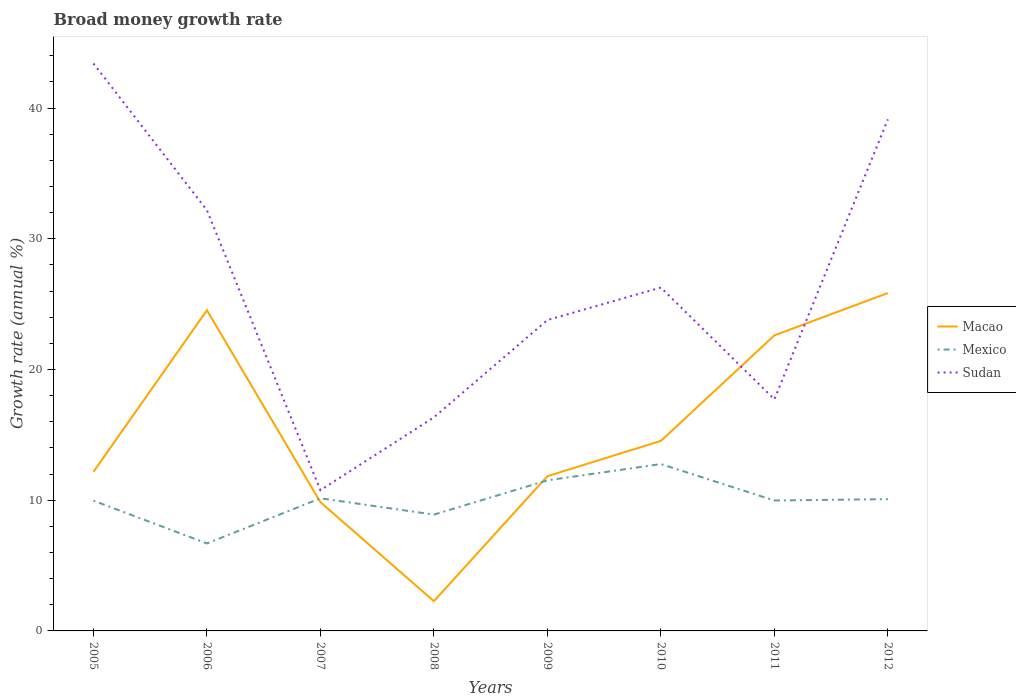How many different coloured lines are there?
Give a very brief answer. 3. Across all years, what is the maximum growth rate in Sudan?
Your response must be concise. 10.77. What is the total growth rate in Mexico in the graph?
Your answer should be very brief. -2.8. What is the difference between the highest and the second highest growth rate in Mexico?
Offer a terse response. 6.07. What is the difference between the highest and the lowest growth rate in Mexico?
Make the answer very short. 4. Is the growth rate in Mexico strictly greater than the growth rate in Sudan over the years?
Make the answer very short. Yes. How many lines are there?
Your answer should be very brief. 3. How many years are there in the graph?
Give a very brief answer. 8. What is the difference between two consecutive major ticks on the Y-axis?
Make the answer very short. 10. Are the values on the major ticks of Y-axis written in scientific E-notation?
Ensure brevity in your answer.  No. Does the graph contain grids?
Offer a terse response. No. How many legend labels are there?
Offer a very short reply. 3. What is the title of the graph?
Your answer should be very brief. Broad money growth rate. What is the label or title of the Y-axis?
Give a very brief answer. Growth rate (annual %). What is the Growth rate (annual %) of Macao in 2005?
Offer a terse response. 12.17. What is the Growth rate (annual %) of Mexico in 2005?
Your answer should be compact. 9.97. What is the Growth rate (annual %) of Sudan in 2005?
Provide a short and direct response. 43.42. What is the Growth rate (annual %) of Macao in 2006?
Your answer should be compact. 24.54. What is the Growth rate (annual %) of Mexico in 2006?
Keep it short and to the point. 6.69. What is the Growth rate (annual %) of Sudan in 2006?
Your answer should be very brief. 32.19. What is the Growth rate (annual %) of Macao in 2007?
Your response must be concise. 9.85. What is the Growth rate (annual %) in Mexico in 2007?
Ensure brevity in your answer.  10.15. What is the Growth rate (annual %) of Sudan in 2007?
Your answer should be compact. 10.77. What is the Growth rate (annual %) of Macao in 2008?
Your response must be concise. 2.28. What is the Growth rate (annual %) in Mexico in 2008?
Make the answer very short. 8.9. What is the Growth rate (annual %) of Sudan in 2008?
Keep it short and to the point. 16.34. What is the Growth rate (annual %) in Macao in 2009?
Provide a short and direct response. 11.84. What is the Growth rate (annual %) in Mexico in 2009?
Offer a terse response. 11.52. What is the Growth rate (annual %) in Sudan in 2009?
Keep it short and to the point. 23.79. What is the Growth rate (annual %) in Macao in 2010?
Provide a succinct answer. 14.54. What is the Growth rate (annual %) in Mexico in 2010?
Offer a very short reply. 12.77. What is the Growth rate (annual %) in Sudan in 2010?
Make the answer very short. 26.27. What is the Growth rate (annual %) of Macao in 2011?
Keep it short and to the point. 22.61. What is the Growth rate (annual %) of Mexico in 2011?
Provide a succinct answer. 9.98. What is the Growth rate (annual %) of Sudan in 2011?
Offer a terse response. 17.72. What is the Growth rate (annual %) in Macao in 2012?
Provide a succinct answer. 25.85. What is the Growth rate (annual %) in Mexico in 2012?
Make the answer very short. 10.08. What is the Growth rate (annual %) in Sudan in 2012?
Give a very brief answer. 39.14. Across all years, what is the maximum Growth rate (annual %) in Macao?
Provide a succinct answer. 25.85. Across all years, what is the maximum Growth rate (annual %) of Mexico?
Keep it short and to the point. 12.77. Across all years, what is the maximum Growth rate (annual %) of Sudan?
Your answer should be compact. 43.42. Across all years, what is the minimum Growth rate (annual %) of Macao?
Your answer should be compact. 2.28. Across all years, what is the minimum Growth rate (annual %) of Mexico?
Keep it short and to the point. 6.69. Across all years, what is the minimum Growth rate (annual %) in Sudan?
Your answer should be compact. 10.77. What is the total Growth rate (annual %) of Macao in the graph?
Make the answer very short. 123.68. What is the total Growth rate (annual %) of Mexico in the graph?
Your answer should be very brief. 80.06. What is the total Growth rate (annual %) of Sudan in the graph?
Give a very brief answer. 209.64. What is the difference between the Growth rate (annual %) in Macao in 2005 and that in 2006?
Offer a terse response. -12.37. What is the difference between the Growth rate (annual %) of Mexico in 2005 and that in 2006?
Keep it short and to the point. 3.28. What is the difference between the Growth rate (annual %) in Sudan in 2005 and that in 2006?
Your answer should be very brief. 11.23. What is the difference between the Growth rate (annual %) of Macao in 2005 and that in 2007?
Your answer should be compact. 2.32. What is the difference between the Growth rate (annual %) of Mexico in 2005 and that in 2007?
Your answer should be very brief. -0.18. What is the difference between the Growth rate (annual %) in Sudan in 2005 and that in 2007?
Your answer should be compact. 32.65. What is the difference between the Growth rate (annual %) of Macao in 2005 and that in 2008?
Your response must be concise. 9.89. What is the difference between the Growth rate (annual %) in Mexico in 2005 and that in 2008?
Provide a succinct answer. 1.07. What is the difference between the Growth rate (annual %) in Sudan in 2005 and that in 2008?
Your answer should be compact. 27.08. What is the difference between the Growth rate (annual %) in Macao in 2005 and that in 2009?
Offer a very short reply. 0.33. What is the difference between the Growth rate (annual %) in Mexico in 2005 and that in 2009?
Your answer should be compact. -1.55. What is the difference between the Growth rate (annual %) of Sudan in 2005 and that in 2009?
Provide a short and direct response. 19.63. What is the difference between the Growth rate (annual %) in Macao in 2005 and that in 2010?
Give a very brief answer. -2.37. What is the difference between the Growth rate (annual %) in Mexico in 2005 and that in 2010?
Ensure brevity in your answer.  -2.8. What is the difference between the Growth rate (annual %) in Sudan in 2005 and that in 2010?
Offer a very short reply. 17.14. What is the difference between the Growth rate (annual %) of Macao in 2005 and that in 2011?
Provide a succinct answer. -10.44. What is the difference between the Growth rate (annual %) in Mexico in 2005 and that in 2011?
Make the answer very short. -0.01. What is the difference between the Growth rate (annual %) of Sudan in 2005 and that in 2011?
Ensure brevity in your answer.  25.7. What is the difference between the Growth rate (annual %) of Macao in 2005 and that in 2012?
Keep it short and to the point. -13.68. What is the difference between the Growth rate (annual %) of Mexico in 2005 and that in 2012?
Make the answer very short. -0.12. What is the difference between the Growth rate (annual %) in Sudan in 2005 and that in 2012?
Ensure brevity in your answer.  4.28. What is the difference between the Growth rate (annual %) of Macao in 2006 and that in 2007?
Make the answer very short. 14.69. What is the difference between the Growth rate (annual %) in Mexico in 2006 and that in 2007?
Make the answer very short. -3.46. What is the difference between the Growth rate (annual %) in Sudan in 2006 and that in 2007?
Make the answer very short. 21.42. What is the difference between the Growth rate (annual %) in Macao in 2006 and that in 2008?
Offer a terse response. 22.26. What is the difference between the Growth rate (annual %) in Mexico in 2006 and that in 2008?
Provide a succinct answer. -2.21. What is the difference between the Growth rate (annual %) in Sudan in 2006 and that in 2008?
Keep it short and to the point. 15.85. What is the difference between the Growth rate (annual %) of Macao in 2006 and that in 2009?
Ensure brevity in your answer.  12.7. What is the difference between the Growth rate (annual %) of Mexico in 2006 and that in 2009?
Provide a succinct answer. -4.83. What is the difference between the Growth rate (annual %) in Sudan in 2006 and that in 2009?
Your response must be concise. 8.4. What is the difference between the Growth rate (annual %) in Macao in 2006 and that in 2010?
Your response must be concise. 10. What is the difference between the Growth rate (annual %) in Mexico in 2006 and that in 2010?
Provide a short and direct response. -6.07. What is the difference between the Growth rate (annual %) of Sudan in 2006 and that in 2010?
Provide a short and direct response. 5.92. What is the difference between the Growth rate (annual %) of Macao in 2006 and that in 2011?
Give a very brief answer. 1.92. What is the difference between the Growth rate (annual %) in Mexico in 2006 and that in 2011?
Give a very brief answer. -3.29. What is the difference between the Growth rate (annual %) in Sudan in 2006 and that in 2011?
Your response must be concise. 14.47. What is the difference between the Growth rate (annual %) in Macao in 2006 and that in 2012?
Keep it short and to the point. -1.31. What is the difference between the Growth rate (annual %) in Mexico in 2006 and that in 2012?
Make the answer very short. -3.39. What is the difference between the Growth rate (annual %) of Sudan in 2006 and that in 2012?
Ensure brevity in your answer.  -6.95. What is the difference between the Growth rate (annual %) in Macao in 2007 and that in 2008?
Offer a terse response. 7.57. What is the difference between the Growth rate (annual %) in Mexico in 2007 and that in 2008?
Ensure brevity in your answer.  1.25. What is the difference between the Growth rate (annual %) of Sudan in 2007 and that in 2008?
Provide a succinct answer. -5.57. What is the difference between the Growth rate (annual %) of Macao in 2007 and that in 2009?
Keep it short and to the point. -1.99. What is the difference between the Growth rate (annual %) of Mexico in 2007 and that in 2009?
Provide a short and direct response. -1.37. What is the difference between the Growth rate (annual %) in Sudan in 2007 and that in 2009?
Make the answer very short. -13.02. What is the difference between the Growth rate (annual %) of Macao in 2007 and that in 2010?
Provide a short and direct response. -4.69. What is the difference between the Growth rate (annual %) of Mexico in 2007 and that in 2010?
Give a very brief answer. -2.62. What is the difference between the Growth rate (annual %) in Sudan in 2007 and that in 2010?
Keep it short and to the point. -15.5. What is the difference between the Growth rate (annual %) of Macao in 2007 and that in 2011?
Ensure brevity in your answer.  -12.76. What is the difference between the Growth rate (annual %) of Mexico in 2007 and that in 2011?
Provide a short and direct response. 0.17. What is the difference between the Growth rate (annual %) of Sudan in 2007 and that in 2011?
Provide a succinct answer. -6.95. What is the difference between the Growth rate (annual %) in Macao in 2007 and that in 2012?
Your answer should be very brief. -16. What is the difference between the Growth rate (annual %) of Mexico in 2007 and that in 2012?
Make the answer very short. 0.06. What is the difference between the Growth rate (annual %) in Sudan in 2007 and that in 2012?
Offer a terse response. -28.37. What is the difference between the Growth rate (annual %) in Macao in 2008 and that in 2009?
Keep it short and to the point. -9.56. What is the difference between the Growth rate (annual %) in Mexico in 2008 and that in 2009?
Offer a terse response. -2.62. What is the difference between the Growth rate (annual %) of Sudan in 2008 and that in 2009?
Ensure brevity in your answer.  -7.45. What is the difference between the Growth rate (annual %) of Macao in 2008 and that in 2010?
Your answer should be very brief. -12.26. What is the difference between the Growth rate (annual %) of Mexico in 2008 and that in 2010?
Your answer should be very brief. -3.87. What is the difference between the Growth rate (annual %) in Sudan in 2008 and that in 2010?
Provide a succinct answer. -9.93. What is the difference between the Growth rate (annual %) of Macao in 2008 and that in 2011?
Keep it short and to the point. -20.34. What is the difference between the Growth rate (annual %) of Mexico in 2008 and that in 2011?
Offer a very short reply. -1.08. What is the difference between the Growth rate (annual %) of Sudan in 2008 and that in 2011?
Keep it short and to the point. -1.38. What is the difference between the Growth rate (annual %) of Macao in 2008 and that in 2012?
Give a very brief answer. -23.57. What is the difference between the Growth rate (annual %) of Mexico in 2008 and that in 2012?
Your response must be concise. -1.19. What is the difference between the Growth rate (annual %) in Sudan in 2008 and that in 2012?
Offer a terse response. -22.8. What is the difference between the Growth rate (annual %) of Macao in 2009 and that in 2010?
Ensure brevity in your answer.  -2.7. What is the difference between the Growth rate (annual %) in Mexico in 2009 and that in 2010?
Your response must be concise. -1.25. What is the difference between the Growth rate (annual %) of Sudan in 2009 and that in 2010?
Provide a succinct answer. -2.49. What is the difference between the Growth rate (annual %) of Macao in 2009 and that in 2011?
Your answer should be compact. -10.77. What is the difference between the Growth rate (annual %) of Mexico in 2009 and that in 2011?
Your response must be concise. 1.54. What is the difference between the Growth rate (annual %) in Sudan in 2009 and that in 2011?
Provide a short and direct response. 6.07. What is the difference between the Growth rate (annual %) in Macao in 2009 and that in 2012?
Offer a very short reply. -14.01. What is the difference between the Growth rate (annual %) of Mexico in 2009 and that in 2012?
Make the answer very short. 1.44. What is the difference between the Growth rate (annual %) of Sudan in 2009 and that in 2012?
Provide a short and direct response. -15.35. What is the difference between the Growth rate (annual %) in Macao in 2010 and that in 2011?
Your answer should be compact. -8.07. What is the difference between the Growth rate (annual %) in Mexico in 2010 and that in 2011?
Make the answer very short. 2.79. What is the difference between the Growth rate (annual %) of Sudan in 2010 and that in 2011?
Offer a very short reply. 8.55. What is the difference between the Growth rate (annual %) of Macao in 2010 and that in 2012?
Provide a succinct answer. -11.31. What is the difference between the Growth rate (annual %) of Mexico in 2010 and that in 2012?
Offer a very short reply. 2.68. What is the difference between the Growth rate (annual %) in Sudan in 2010 and that in 2012?
Ensure brevity in your answer.  -12.87. What is the difference between the Growth rate (annual %) in Macao in 2011 and that in 2012?
Provide a short and direct response. -3.24. What is the difference between the Growth rate (annual %) in Mexico in 2011 and that in 2012?
Ensure brevity in your answer.  -0.1. What is the difference between the Growth rate (annual %) in Sudan in 2011 and that in 2012?
Offer a terse response. -21.42. What is the difference between the Growth rate (annual %) of Macao in 2005 and the Growth rate (annual %) of Mexico in 2006?
Your answer should be compact. 5.48. What is the difference between the Growth rate (annual %) of Macao in 2005 and the Growth rate (annual %) of Sudan in 2006?
Provide a short and direct response. -20.02. What is the difference between the Growth rate (annual %) of Mexico in 2005 and the Growth rate (annual %) of Sudan in 2006?
Offer a very short reply. -22.22. What is the difference between the Growth rate (annual %) of Macao in 2005 and the Growth rate (annual %) of Mexico in 2007?
Your answer should be compact. 2.02. What is the difference between the Growth rate (annual %) in Macao in 2005 and the Growth rate (annual %) in Sudan in 2007?
Your response must be concise. 1.4. What is the difference between the Growth rate (annual %) of Mexico in 2005 and the Growth rate (annual %) of Sudan in 2007?
Provide a succinct answer. -0.8. What is the difference between the Growth rate (annual %) of Macao in 2005 and the Growth rate (annual %) of Mexico in 2008?
Your response must be concise. 3.27. What is the difference between the Growth rate (annual %) of Macao in 2005 and the Growth rate (annual %) of Sudan in 2008?
Your answer should be compact. -4.17. What is the difference between the Growth rate (annual %) in Mexico in 2005 and the Growth rate (annual %) in Sudan in 2008?
Your answer should be very brief. -6.37. What is the difference between the Growth rate (annual %) of Macao in 2005 and the Growth rate (annual %) of Mexico in 2009?
Ensure brevity in your answer.  0.65. What is the difference between the Growth rate (annual %) of Macao in 2005 and the Growth rate (annual %) of Sudan in 2009?
Your answer should be compact. -11.62. What is the difference between the Growth rate (annual %) in Mexico in 2005 and the Growth rate (annual %) in Sudan in 2009?
Make the answer very short. -13.82. What is the difference between the Growth rate (annual %) in Macao in 2005 and the Growth rate (annual %) in Mexico in 2010?
Provide a short and direct response. -0.6. What is the difference between the Growth rate (annual %) in Macao in 2005 and the Growth rate (annual %) in Sudan in 2010?
Keep it short and to the point. -14.1. What is the difference between the Growth rate (annual %) of Mexico in 2005 and the Growth rate (annual %) of Sudan in 2010?
Offer a very short reply. -16.3. What is the difference between the Growth rate (annual %) in Macao in 2005 and the Growth rate (annual %) in Mexico in 2011?
Ensure brevity in your answer.  2.19. What is the difference between the Growth rate (annual %) in Macao in 2005 and the Growth rate (annual %) in Sudan in 2011?
Give a very brief answer. -5.55. What is the difference between the Growth rate (annual %) in Mexico in 2005 and the Growth rate (annual %) in Sudan in 2011?
Provide a short and direct response. -7.75. What is the difference between the Growth rate (annual %) of Macao in 2005 and the Growth rate (annual %) of Mexico in 2012?
Offer a terse response. 2.09. What is the difference between the Growth rate (annual %) of Macao in 2005 and the Growth rate (annual %) of Sudan in 2012?
Your answer should be very brief. -26.97. What is the difference between the Growth rate (annual %) in Mexico in 2005 and the Growth rate (annual %) in Sudan in 2012?
Offer a terse response. -29.17. What is the difference between the Growth rate (annual %) in Macao in 2006 and the Growth rate (annual %) in Mexico in 2007?
Ensure brevity in your answer.  14.39. What is the difference between the Growth rate (annual %) in Macao in 2006 and the Growth rate (annual %) in Sudan in 2007?
Provide a succinct answer. 13.77. What is the difference between the Growth rate (annual %) of Mexico in 2006 and the Growth rate (annual %) of Sudan in 2007?
Keep it short and to the point. -4.08. What is the difference between the Growth rate (annual %) in Macao in 2006 and the Growth rate (annual %) in Mexico in 2008?
Provide a short and direct response. 15.64. What is the difference between the Growth rate (annual %) of Macao in 2006 and the Growth rate (annual %) of Sudan in 2008?
Offer a terse response. 8.2. What is the difference between the Growth rate (annual %) of Mexico in 2006 and the Growth rate (annual %) of Sudan in 2008?
Offer a terse response. -9.65. What is the difference between the Growth rate (annual %) of Macao in 2006 and the Growth rate (annual %) of Mexico in 2009?
Your response must be concise. 13.02. What is the difference between the Growth rate (annual %) of Macao in 2006 and the Growth rate (annual %) of Sudan in 2009?
Make the answer very short. 0.75. What is the difference between the Growth rate (annual %) of Mexico in 2006 and the Growth rate (annual %) of Sudan in 2009?
Keep it short and to the point. -17.09. What is the difference between the Growth rate (annual %) of Macao in 2006 and the Growth rate (annual %) of Mexico in 2010?
Your answer should be compact. 11.77. What is the difference between the Growth rate (annual %) of Macao in 2006 and the Growth rate (annual %) of Sudan in 2010?
Provide a succinct answer. -1.74. What is the difference between the Growth rate (annual %) in Mexico in 2006 and the Growth rate (annual %) in Sudan in 2010?
Your answer should be compact. -19.58. What is the difference between the Growth rate (annual %) in Macao in 2006 and the Growth rate (annual %) in Mexico in 2011?
Your response must be concise. 14.56. What is the difference between the Growth rate (annual %) of Macao in 2006 and the Growth rate (annual %) of Sudan in 2011?
Your answer should be compact. 6.82. What is the difference between the Growth rate (annual %) of Mexico in 2006 and the Growth rate (annual %) of Sudan in 2011?
Offer a terse response. -11.03. What is the difference between the Growth rate (annual %) of Macao in 2006 and the Growth rate (annual %) of Mexico in 2012?
Give a very brief answer. 14.45. What is the difference between the Growth rate (annual %) of Macao in 2006 and the Growth rate (annual %) of Sudan in 2012?
Offer a terse response. -14.6. What is the difference between the Growth rate (annual %) of Mexico in 2006 and the Growth rate (annual %) of Sudan in 2012?
Ensure brevity in your answer.  -32.45. What is the difference between the Growth rate (annual %) in Macao in 2007 and the Growth rate (annual %) in Mexico in 2008?
Keep it short and to the point. 0.95. What is the difference between the Growth rate (annual %) in Macao in 2007 and the Growth rate (annual %) in Sudan in 2008?
Your response must be concise. -6.49. What is the difference between the Growth rate (annual %) of Mexico in 2007 and the Growth rate (annual %) of Sudan in 2008?
Offer a terse response. -6.19. What is the difference between the Growth rate (annual %) of Macao in 2007 and the Growth rate (annual %) of Mexico in 2009?
Provide a succinct answer. -1.67. What is the difference between the Growth rate (annual %) in Macao in 2007 and the Growth rate (annual %) in Sudan in 2009?
Make the answer very short. -13.94. What is the difference between the Growth rate (annual %) in Mexico in 2007 and the Growth rate (annual %) in Sudan in 2009?
Give a very brief answer. -13.64. What is the difference between the Growth rate (annual %) of Macao in 2007 and the Growth rate (annual %) of Mexico in 2010?
Give a very brief answer. -2.92. What is the difference between the Growth rate (annual %) of Macao in 2007 and the Growth rate (annual %) of Sudan in 2010?
Offer a very short reply. -16.42. What is the difference between the Growth rate (annual %) in Mexico in 2007 and the Growth rate (annual %) in Sudan in 2010?
Give a very brief answer. -16.12. What is the difference between the Growth rate (annual %) in Macao in 2007 and the Growth rate (annual %) in Mexico in 2011?
Your response must be concise. -0.13. What is the difference between the Growth rate (annual %) in Macao in 2007 and the Growth rate (annual %) in Sudan in 2011?
Ensure brevity in your answer.  -7.87. What is the difference between the Growth rate (annual %) in Mexico in 2007 and the Growth rate (annual %) in Sudan in 2011?
Your answer should be compact. -7.57. What is the difference between the Growth rate (annual %) in Macao in 2007 and the Growth rate (annual %) in Mexico in 2012?
Give a very brief answer. -0.24. What is the difference between the Growth rate (annual %) of Macao in 2007 and the Growth rate (annual %) of Sudan in 2012?
Provide a succinct answer. -29.29. What is the difference between the Growth rate (annual %) in Mexico in 2007 and the Growth rate (annual %) in Sudan in 2012?
Make the answer very short. -28.99. What is the difference between the Growth rate (annual %) of Macao in 2008 and the Growth rate (annual %) of Mexico in 2009?
Your answer should be very brief. -9.24. What is the difference between the Growth rate (annual %) in Macao in 2008 and the Growth rate (annual %) in Sudan in 2009?
Provide a succinct answer. -21.51. What is the difference between the Growth rate (annual %) in Mexico in 2008 and the Growth rate (annual %) in Sudan in 2009?
Keep it short and to the point. -14.89. What is the difference between the Growth rate (annual %) in Macao in 2008 and the Growth rate (annual %) in Mexico in 2010?
Keep it short and to the point. -10.49. What is the difference between the Growth rate (annual %) in Macao in 2008 and the Growth rate (annual %) in Sudan in 2010?
Make the answer very short. -24. What is the difference between the Growth rate (annual %) of Mexico in 2008 and the Growth rate (annual %) of Sudan in 2010?
Your answer should be compact. -17.37. What is the difference between the Growth rate (annual %) in Macao in 2008 and the Growth rate (annual %) in Mexico in 2011?
Make the answer very short. -7.7. What is the difference between the Growth rate (annual %) of Macao in 2008 and the Growth rate (annual %) of Sudan in 2011?
Offer a terse response. -15.44. What is the difference between the Growth rate (annual %) in Mexico in 2008 and the Growth rate (annual %) in Sudan in 2011?
Your response must be concise. -8.82. What is the difference between the Growth rate (annual %) of Macao in 2008 and the Growth rate (annual %) of Mexico in 2012?
Make the answer very short. -7.81. What is the difference between the Growth rate (annual %) in Macao in 2008 and the Growth rate (annual %) in Sudan in 2012?
Ensure brevity in your answer.  -36.86. What is the difference between the Growth rate (annual %) in Mexico in 2008 and the Growth rate (annual %) in Sudan in 2012?
Your answer should be very brief. -30.24. What is the difference between the Growth rate (annual %) of Macao in 2009 and the Growth rate (annual %) of Mexico in 2010?
Provide a succinct answer. -0.93. What is the difference between the Growth rate (annual %) in Macao in 2009 and the Growth rate (annual %) in Sudan in 2010?
Your answer should be compact. -14.43. What is the difference between the Growth rate (annual %) in Mexico in 2009 and the Growth rate (annual %) in Sudan in 2010?
Make the answer very short. -14.75. What is the difference between the Growth rate (annual %) of Macao in 2009 and the Growth rate (annual %) of Mexico in 2011?
Ensure brevity in your answer.  1.86. What is the difference between the Growth rate (annual %) of Macao in 2009 and the Growth rate (annual %) of Sudan in 2011?
Provide a short and direct response. -5.88. What is the difference between the Growth rate (annual %) in Mexico in 2009 and the Growth rate (annual %) in Sudan in 2011?
Give a very brief answer. -6.2. What is the difference between the Growth rate (annual %) of Macao in 2009 and the Growth rate (annual %) of Mexico in 2012?
Your response must be concise. 1.76. What is the difference between the Growth rate (annual %) of Macao in 2009 and the Growth rate (annual %) of Sudan in 2012?
Make the answer very short. -27.3. What is the difference between the Growth rate (annual %) in Mexico in 2009 and the Growth rate (annual %) in Sudan in 2012?
Provide a short and direct response. -27.62. What is the difference between the Growth rate (annual %) of Macao in 2010 and the Growth rate (annual %) of Mexico in 2011?
Offer a terse response. 4.56. What is the difference between the Growth rate (annual %) in Macao in 2010 and the Growth rate (annual %) in Sudan in 2011?
Your response must be concise. -3.18. What is the difference between the Growth rate (annual %) of Mexico in 2010 and the Growth rate (annual %) of Sudan in 2011?
Offer a very short reply. -4.95. What is the difference between the Growth rate (annual %) of Macao in 2010 and the Growth rate (annual %) of Mexico in 2012?
Your answer should be very brief. 4.46. What is the difference between the Growth rate (annual %) in Macao in 2010 and the Growth rate (annual %) in Sudan in 2012?
Keep it short and to the point. -24.6. What is the difference between the Growth rate (annual %) in Mexico in 2010 and the Growth rate (annual %) in Sudan in 2012?
Provide a short and direct response. -26.37. What is the difference between the Growth rate (annual %) of Macao in 2011 and the Growth rate (annual %) of Mexico in 2012?
Keep it short and to the point. 12.53. What is the difference between the Growth rate (annual %) in Macao in 2011 and the Growth rate (annual %) in Sudan in 2012?
Keep it short and to the point. -16.53. What is the difference between the Growth rate (annual %) in Mexico in 2011 and the Growth rate (annual %) in Sudan in 2012?
Your answer should be very brief. -29.16. What is the average Growth rate (annual %) of Macao per year?
Offer a terse response. 15.46. What is the average Growth rate (annual %) of Mexico per year?
Your answer should be very brief. 10.01. What is the average Growth rate (annual %) of Sudan per year?
Make the answer very short. 26.2. In the year 2005, what is the difference between the Growth rate (annual %) in Macao and Growth rate (annual %) in Mexico?
Your answer should be compact. 2.2. In the year 2005, what is the difference between the Growth rate (annual %) of Macao and Growth rate (annual %) of Sudan?
Keep it short and to the point. -31.25. In the year 2005, what is the difference between the Growth rate (annual %) in Mexico and Growth rate (annual %) in Sudan?
Offer a very short reply. -33.45. In the year 2006, what is the difference between the Growth rate (annual %) in Macao and Growth rate (annual %) in Mexico?
Your answer should be compact. 17.84. In the year 2006, what is the difference between the Growth rate (annual %) of Macao and Growth rate (annual %) of Sudan?
Your answer should be very brief. -7.65. In the year 2006, what is the difference between the Growth rate (annual %) of Mexico and Growth rate (annual %) of Sudan?
Ensure brevity in your answer.  -25.5. In the year 2007, what is the difference between the Growth rate (annual %) in Macao and Growth rate (annual %) in Mexico?
Your answer should be very brief. -0.3. In the year 2007, what is the difference between the Growth rate (annual %) of Macao and Growth rate (annual %) of Sudan?
Your answer should be compact. -0.92. In the year 2007, what is the difference between the Growth rate (annual %) of Mexico and Growth rate (annual %) of Sudan?
Your response must be concise. -0.62. In the year 2008, what is the difference between the Growth rate (annual %) in Macao and Growth rate (annual %) in Mexico?
Your answer should be compact. -6.62. In the year 2008, what is the difference between the Growth rate (annual %) in Macao and Growth rate (annual %) in Sudan?
Keep it short and to the point. -14.07. In the year 2008, what is the difference between the Growth rate (annual %) in Mexico and Growth rate (annual %) in Sudan?
Ensure brevity in your answer.  -7.44. In the year 2009, what is the difference between the Growth rate (annual %) in Macao and Growth rate (annual %) in Mexico?
Give a very brief answer. 0.32. In the year 2009, what is the difference between the Growth rate (annual %) in Macao and Growth rate (annual %) in Sudan?
Offer a terse response. -11.95. In the year 2009, what is the difference between the Growth rate (annual %) of Mexico and Growth rate (annual %) of Sudan?
Keep it short and to the point. -12.27. In the year 2010, what is the difference between the Growth rate (annual %) in Macao and Growth rate (annual %) in Mexico?
Give a very brief answer. 1.77. In the year 2010, what is the difference between the Growth rate (annual %) of Macao and Growth rate (annual %) of Sudan?
Provide a succinct answer. -11.73. In the year 2010, what is the difference between the Growth rate (annual %) in Mexico and Growth rate (annual %) in Sudan?
Keep it short and to the point. -13.51. In the year 2011, what is the difference between the Growth rate (annual %) of Macao and Growth rate (annual %) of Mexico?
Offer a terse response. 12.63. In the year 2011, what is the difference between the Growth rate (annual %) in Macao and Growth rate (annual %) in Sudan?
Keep it short and to the point. 4.89. In the year 2011, what is the difference between the Growth rate (annual %) in Mexico and Growth rate (annual %) in Sudan?
Your answer should be very brief. -7.74. In the year 2012, what is the difference between the Growth rate (annual %) of Macao and Growth rate (annual %) of Mexico?
Make the answer very short. 15.77. In the year 2012, what is the difference between the Growth rate (annual %) in Macao and Growth rate (annual %) in Sudan?
Your response must be concise. -13.29. In the year 2012, what is the difference between the Growth rate (annual %) of Mexico and Growth rate (annual %) of Sudan?
Your answer should be very brief. -29.06. What is the ratio of the Growth rate (annual %) of Macao in 2005 to that in 2006?
Provide a short and direct response. 0.5. What is the ratio of the Growth rate (annual %) in Mexico in 2005 to that in 2006?
Your response must be concise. 1.49. What is the ratio of the Growth rate (annual %) of Sudan in 2005 to that in 2006?
Give a very brief answer. 1.35. What is the ratio of the Growth rate (annual %) of Macao in 2005 to that in 2007?
Keep it short and to the point. 1.24. What is the ratio of the Growth rate (annual %) in Mexico in 2005 to that in 2007?
Provide a succinct answer. 0.98. What is the ratio of the Growth rate (annual %) in Sudan in 2005 to that in 2007?
Provide a short and direct response. 4.03. What is the ratio of the Growth rate (annual %) of Macao in 2005 to that in 2008?
Give a very brief answer. 5.35. What is the ratio of the Growth rate (annual %) of Mexico in 2005 to that in 2008?
Offer a very short reply. 1.12. What is the ratio of the Growth rate (annual %) of Sudan in 2005 to that in 2008?
Your response must be concise. 2.66. What is the ratio of the Growth rate (annual %) of Macao in 2005 to that in 2009?
Make the answer very short. 1.03. What is the ratio of the Growth rate (annual %) in Mexico in 2005 to that in 2009?
Your answer should be very brief. 0.87. What is the ratio of the Growth rate (annual %) in Sudan in 2005 to that in 2009?
Provide a short and direct response. 1.83. What is the ratio of the Growth rate (annual %) of Macao in 2005 to that in 2010?
Offer a terse response. 0.84. What is the ratio of the Growth rate (annual %) in Mexico in 2005 to that in 2010?
Make the answer very short. 0.78. What is the ratio of the Growth rate (annual %) of Sudan in 2005 to that in 2010?
Give a very brief answer. 1.65. What is the ratio of the Growth rate (annual %) in Macao in 2005 to that in 2011?
Ensure brevity in your answer.  0.54. What is the ratio of the Growth rate (annual %) in Mexico in 2005 to that in 2011?
Your response must be concise. 1. What is the ratio of the Growth rate (annual %) in Sudan in 2005 to that in 2011?
Keep it short and to the point. 2.45. What is the ratio of the Growth rate (annual %) of Macao in 2005 to that in 2012?
Offer a very short reply. 0.47. What is the ratio of the Growth rate (annual %) in Mexico in 2005 to that in 2012?
Ensure brevity in your answer.  0.99. What is the ratio of the Growth rate (annual %) of Sudan in 2005 to that in 2012?
Offer a very short reply. 1.11. What is the ratio of the Growth rate (annual %) of Macao in 2006 to that in 2007?
Offer a very short reply. 2.49. What is the ratio of the Growth rate (annual %) of Mexico in 2006 to that in 2007?
Your answer should be very brief. 0.66. What is the ratio of the Growth rate (annual %) of Sudan in 2006 to that in 2007?
Give a very brief answer. 2.99. What is the ratio of the Growth rate (annual %) in Macao in 2006 to that in 2008?
Ensure brevity in your answer.  10.78. What is the ratio of the Growth rate (annual %) of Mexico in 2006 to that in 2008?
Provide a succinct answer. 0.75. What is the ratio of the Growth rate (annual %) of Sudan in 2006 to that in 2008?
Your answer should be compact. 1.97. What is the ratio of the Growth rate (annual %) of Macao in 2006 to that in 2009?
Make the answer very short. 2.07. What is the ratio of the Growth rate (annual %) of Mexico in 2006 to that in 2009?
Provide a short and direct response. 0.58. What is the ratio of the Growth rate (annual %) of Sudan in 2006 to that in 2009?
Ensure brevity in your answer.  1.35. What is the ratio of the Growth rate (annual %) in Macao in 2006 to that in 2010?
Provide a succinct answer. 1.69. What is the ratio of the Growth rate (annual %) in Mexico in 2006 to that in 2010?
Your answer should be very brief. 0.52. What is the ratio of the Growth rate (annual %) in Sudan in 2006 to that in 2010?
Your answer should be compact. 1.23. What is the ratio of the Growth rate (annual %) in Macao in 2006 to that in 2011?
Provide a short and direct response. 1.09. What is the ratio of the Growth rate (annual %) in Mexico in 2006 to that in 2011?
Your response must be concise. 0.67. What is the ratio of the Growth rate (annual %) of Sudan in 2006 to that in 2011?
Ensure brevity in your answer.  1.82. What is the ratio of the Growth rate (annual %) in Macao in 2006 to that in 2012?
Your answer should be compact. 0.95. What is the ratio of the Growth rate (annual %) in Mexico in 2006 to that in 2012?
Provide a short and direct response. 0.66. What is the ratio of the Growth rate (annual %) of Sudan in 2006 to that in 2012?
Make the answer very short. 0.82. What is the ratio of the Growth rate (annual %) of Macao in 2007 to that in 2008?
Ensure brevity in your answer.  4.33. What is the ratio of the Growth rate (annual %) of Mexico in 2007 to that in 2008?
Keep it short and to the point. 1.14. What is the ratio of the Growth rate (annual %) of Sudan in 2007 to that in 2008?
Offer a very short reply. 0.66. What is the ratio of the Growth rate (annual %) of Macao in 2007 to that in 2009?
Provide a succinct answer. 0.83. What is the ratio of the Growth rate (annual %) of Mexico in 2007 to that in 2009?
Make the answer very short. 0.88. What is the ratio of the Growth rate (annual %) of Sudan in 2007 to that in 2009?
Provide a succinct answer. 0.45. What is the ratio of the Growth rate (annual %) of Macao in 2007 to that in 2010?
Provide a short and direct response. 0.68. What is the ratio of the Growth rate (annual %) of Mexico in 2007 to that in 2010?
Keep it short and to the point. 0.79. What is the ratio of the Growth rate (annual %) in Sudan in 2007 to that in 2010?
Provide a succinct answer. 0.41. What is the ratio of the Growth rate (annual %) in Macao in 2007 to that in 2011?
Make the answer very short. 0.44. What is the ratio of the Growth rate (annual %) in Mexico in 2007 to that in 2011?
Provide a succinct answer. 1.02. What is the ratio of the Growth rate (annual %) of Sudan in 2007 to that in 2011?
Ensure brevity in your answer.  0.61. What is the ratio of the Growth rate (annual %) of Macao in 2007 to that in 2012?
Provide a succinct answer. 0.38. What is the ratio of the Growth rate (annual %) of Sudan in 2007 to that in 2012?
Offer a very short reply. 0.28. What is the ratio of the Growth rate (annual %) in Macao in 2008 to that in 2009?
Your response must be concise. 0.19. What is the ratio of the Growth rate (annual %) in Mexico in 2008 to that in 2009?
Provide a succinct answer. 0.77. What is the ratio of the Growth rate (annual %) of Sudan in 2008 to that in 2009?
Make the answer very short. 0.69. What is the ratio of the Growth rate (annual %) in Macao in 2008 to that in 2010?
Your answer should be compact. 0.16. What is the ratio of the Growth rate (annual %) in Mexico in 2008 to that in 2010?
Offer a terse response. 0.7. What is the ratio of the Growth rate (annual %) of Sudan in 2008 to that in 2010?
Provide a short and direct response. 0.62. What is the ratio of the Growth rate (annual %) in Macao in 2008 to that in 2011?
Your answer should be compact. 0.1. What is the ratio of the Growth rate (annual %) of Mexico in 2008 to that in 2011?
Provide a succinct answer. 0.89. What is the ratio of the Growth rate (annual %) of Sudan in 2008 to that in 2011?
Your answer should be compact. 0.92. What is the ratio of the Growth rate (annual %) in Macao in 2008 to that in 2012?
Keep it short and to the point. 0.09. What is the ratio of the Growth rate (annual %) of Mexico in 2008 to that in 2012?
Your answer should be compact. 0.88. What is the ratio of the Growth rate (annual %) in Sudan in 2008 to that in 2012?
Offer a terse response. 0.42. What is the ratio of the Growth rate (annual %) in Macao in 2009 to that in 2010?
Make the answer very short. 0.81. What is the ratio of the Growth rate (annual %) in Mexico in 2009 to that in 2010?
Keep it short and to the point. 0.9. What is the ratio of the Growth rate (annual %) in Sudan in 2009 to that in 2010?
Your answer should be compact. 0.91. What is the ratio of the Growth rate (annual %) in Macao in 2009 to that in 2011?
Your answer should be very brief. 0.52. What is the ratio of the Growth rate (annual %) in Mexico in 2009 to that in 2011?
Offer a very short reply. 1.15. What is the ratio of the Growth rate (annual %) of Sudan in 2009 to that in 2011?
Your answer should be very brief. 1.34. What is the ratio of the Growth rate (annual %) of Macao in 2009 to that in 2012?
Keep it short and to the point. 0.46. What is the ratio of the Growth rate (annual %) of Mexico in 2009 to that in 2012?
Ensure brevity in your answer.  1.14. What is the ratio of the Growth rate (annual %) in Sudan in 2009 to that in 2012?
Keep it short and to the point. 0.61. What is the ratio of the Growth rate (annual %) of Macao in 2010 to that in 2011?
Offer a very short reply. 0.64. What is the ratio of the Growth rate (annual %) in Mexico in 2010 to that in 2011?
Provide a short and direct response. 1.28. What is the ratio of the Growth rate (annual %) of Sudan in 2010 to that in 2011?
Keep it short and to the point. 1.48. What is the ratio of the Growth rate (annual %) of Macao in 2010 to that in 2012?
Offer a very short reply. 0.56. What is the ratio of the Growth rate (annual %) of Mexico in 2010 to that in 2012?
Provide a short and direct response. 1.27. What is the ratio of the Growth rate (annual %) in Sudan in 2010 to that in 2012?
Offer a very short reply. 0.67. What is the ratio of the Growth rate (annual %) of Macao in 2011 to that in 2012?
Keep it short and to the point. 0.87. What is the ratio of the Growth rate (annual %) of Sudan in 2011 to that in 2012?
Your answer should be compact. 0.45. What is the difference between the highest and the second highest Growth rate (annual %) in Macao?
Your answer should be compact. 1.31. What is the difference between the highest and the second highest Growth rate (annual %) in Mexico?
Provide a succinct answer. 1.25. What is the difference between the highest and the second highest Growth rate (annual %) in Sudan?
Make the answer very short. 4.28. What is the difference between the highest and the lowest Growth rate (annual %) in Macao?
Offer a terse response. 23.57. What is the difference between the highest and the lowest Growth rate (annual %) in Mexico?
Your answer should be very brief. 6.07. What is the difference between the highest and the lowest Growth rate (annual %) in Sudan?
Offer a terse response. 32.65. 